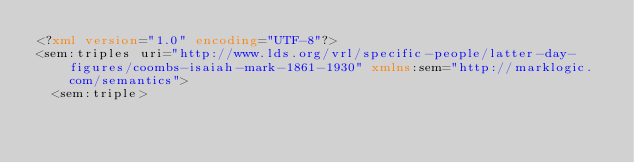Convert code to text. <code><loc_0><loc_0><loc_500><loc_500><_XML_><?xml version="1.0" encoding="UTF-8"?>
<sem:triples uri="http://www.lds.org/vrl/specific-people/latter-day-figures/coombs-isaiah-mark-1861-1930" xmlns:sem="http://marklogic.com/semantics">
  <sem:triple></code> 